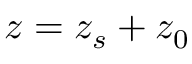Convert formula to latex. <formula><loc_0><loc_0><loc_500><loc_500>z = z _ { s } + z _ { 0 }</formula> 